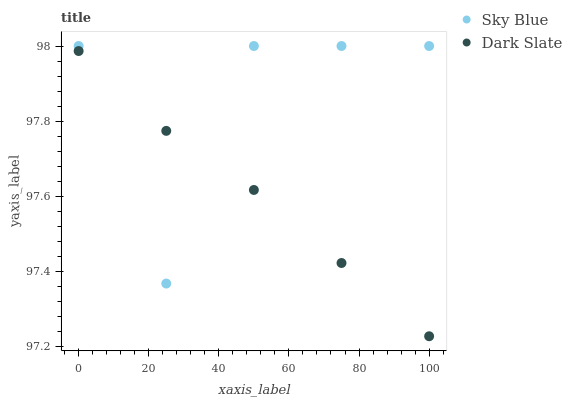Does Dark Slate have the minimum area under the curve?
Answer yes or no. Yes. Does Sky Blue have the maximum area under the curve?
Answer yes or no. Yes. Does Dark Slate have the maximum area under the curve?
Answer yes or no. No. Is Dark Slate the smoothest?
Answer yes or no. Yes. Is Sky Blue the roughest?
Answer yes or no. Yes. Is Dark Slate the roughest?
Answer yes or no. No. Does Dark Slate have the lowest value?
Answer yes or no. Yes. Does Sky Blue have the highest value?
Answer yes or no. Yes. Does Dark Slate have the highest value?
Answer yes or no. No. Does Dark Slate intersect Sky Blue?
Answer yes or no. Yes. Is Dark Slate less than Sky Blue?
Answer yes or no. No. Is Dark Slate greater than Sky Blue?
Answer yes or no. No. 